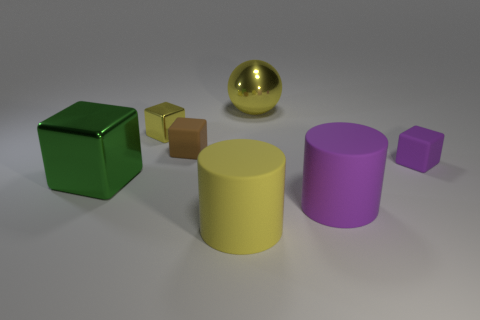Subtract all blue cubes. Subtract all cyan cylinders. How many cubes are left? 4 Add 3 brown rubber objects. How many objects exist? 10 Subtract all blocks. How many objects are left? 3 Add 1 brown matte blocks. How many brown matte blocks are left? 2 Add 6 brown cylinders. How many brown cylinders exist? 6 Subtract 0 blue blocks. How many objects are left? 7 Subtract all tiny red blocks. Subtract all tiny cubes. How many objects are left? 4 